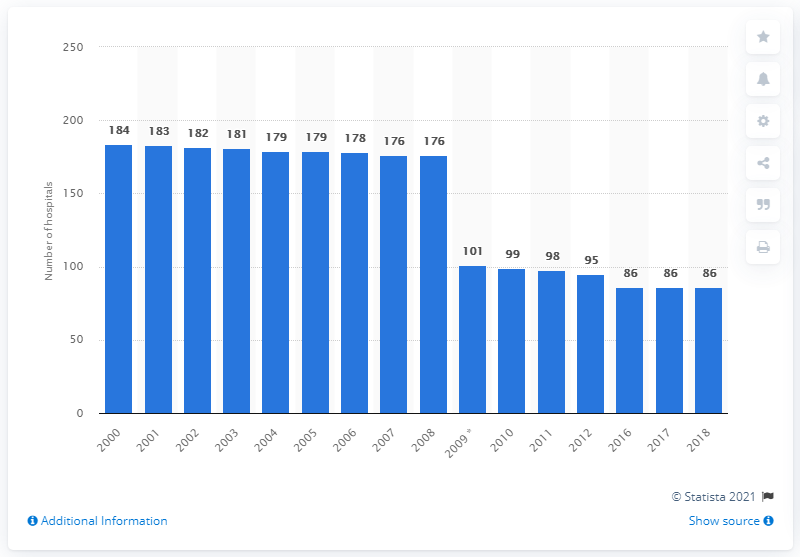Identify some key points in this picture. There were 86 hospitals in Ireland in 2018. 